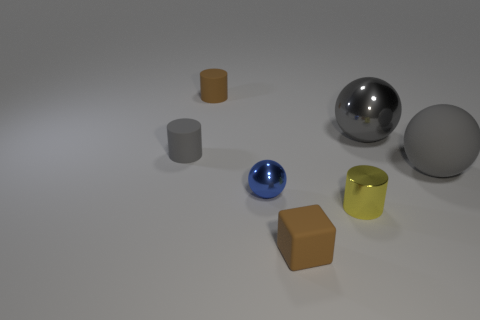Add 2 large spheres. How many objects exist? 9 Subtract all cylinders. How many objects are left? 4 Subtract all cubes. Subtract all small metallic cylinders. How many objects are left? 5 Add 6 blue things. How many blue things are left? 7 Add 3 purple rubber things. How many purple rubber things exist? 3 Subtract 0 red cylinders. How many objects are left? 7 